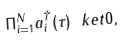Convert formula to latex. <formula><loc_0><loc_0><loc_500><loc_500>\Pi _ { i = 1 } ^ { N } a _ { i } ^ { \dagger } ( \tau ) \ k e t { 0 } ,</formula> 